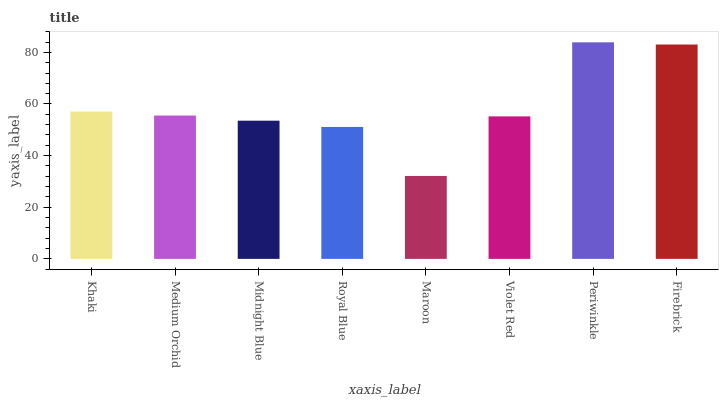Is Maroon the minimum?
Answer yes or no. Yes. Is Periwinkle the maximum?
Answer yes or no. Yes. Is Medium Orchid the minimum?
Answer yes or no. No. Is Medium Orchid the maximum?
Answer yes or no. No. Is Khaki greater than Medium Orchid?
Answer yes or no. Yes. Is Medium Orchid less than Khaki?
Answer yes or no. Yes. Is Medium Orchid greater than Khaki?
Answer yes or no. No. Is Khaki less than Medium Orchid?
Answer yes or no. No. Is Medium Orchid the high median?
Answer yes or no. Yes. Is Violet Red the low median?
Answer yes or no. Yes. Is Firebrick the high median?
Answer yes or no. No. Is Royal Blue the low median?
Answer yes or no. No. 